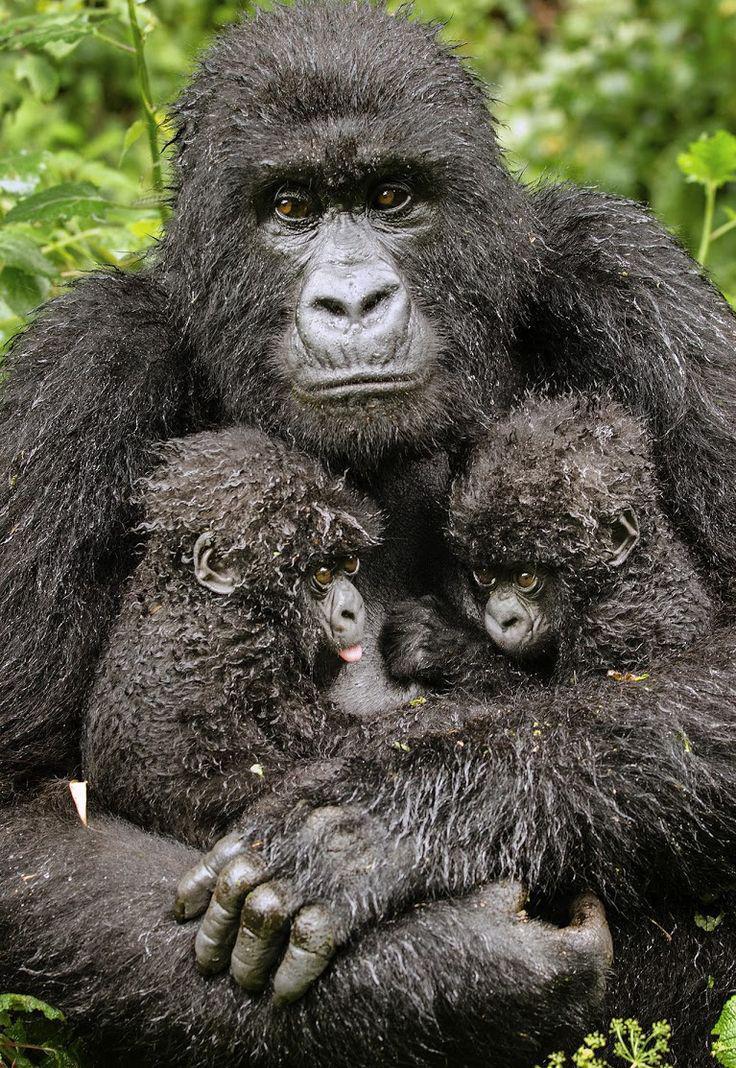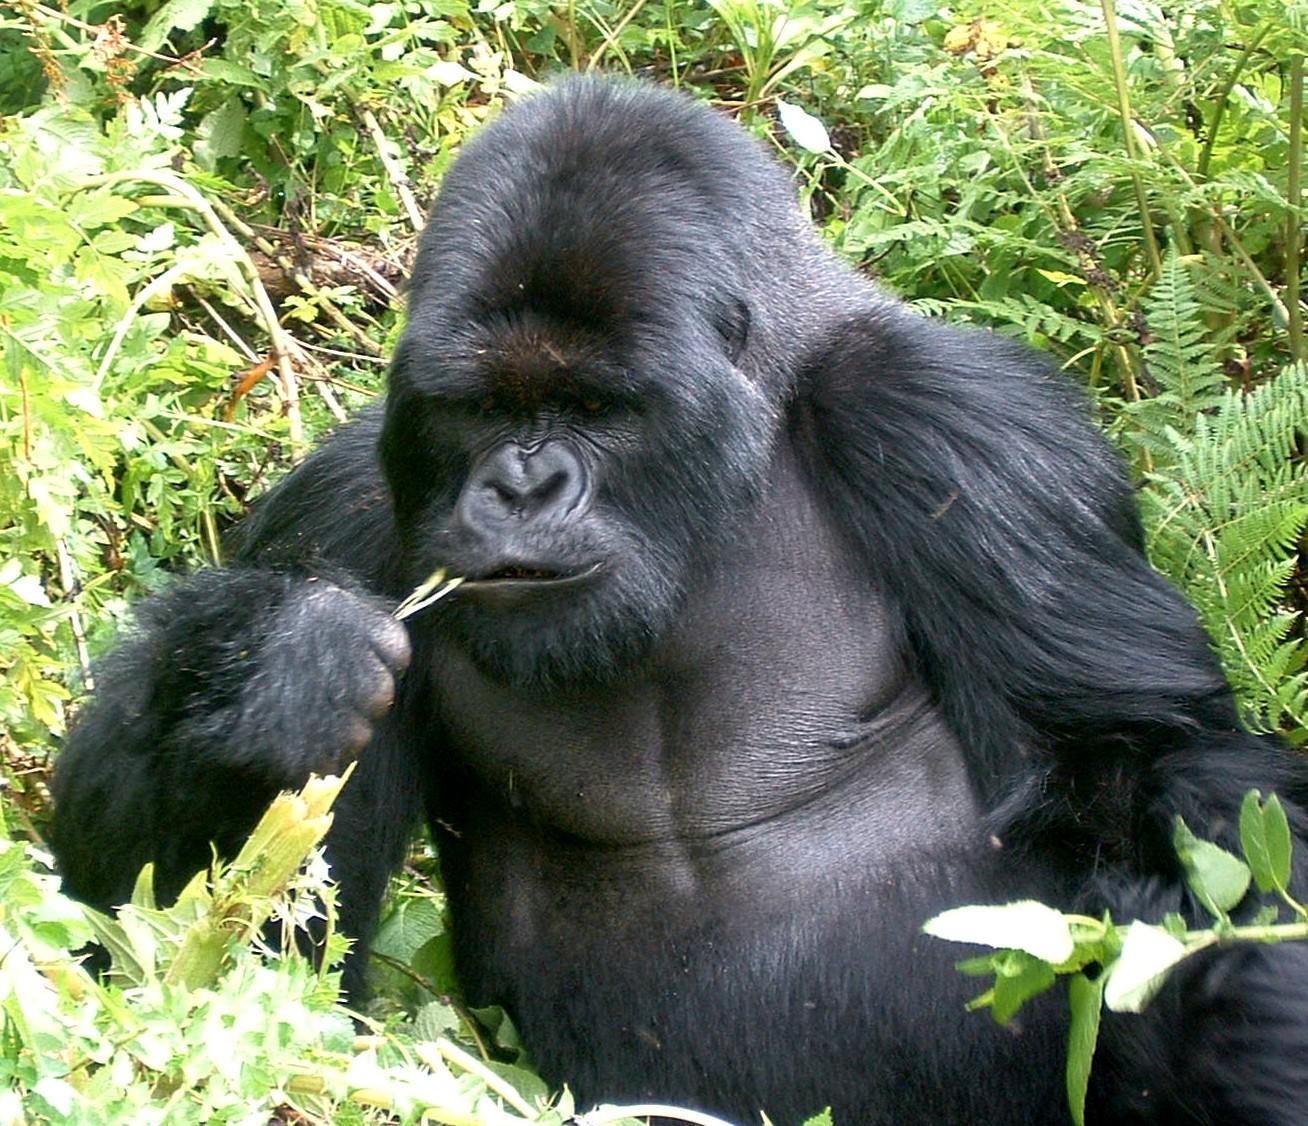The first image is the image on the left, the second image is the image on the right. Assess this claim about the two images: "One image shows an adult gorilla with two infant gorillas held to its chest.". Correct or not? Answer yes or no. Yes. The first image is the image on the left, the second image is the image on the right. Examine the images to the left and right. Is the description "An adult primate holds two of its young close to its chest in the image on the left." accurate? Answer yes or no. Yes. 